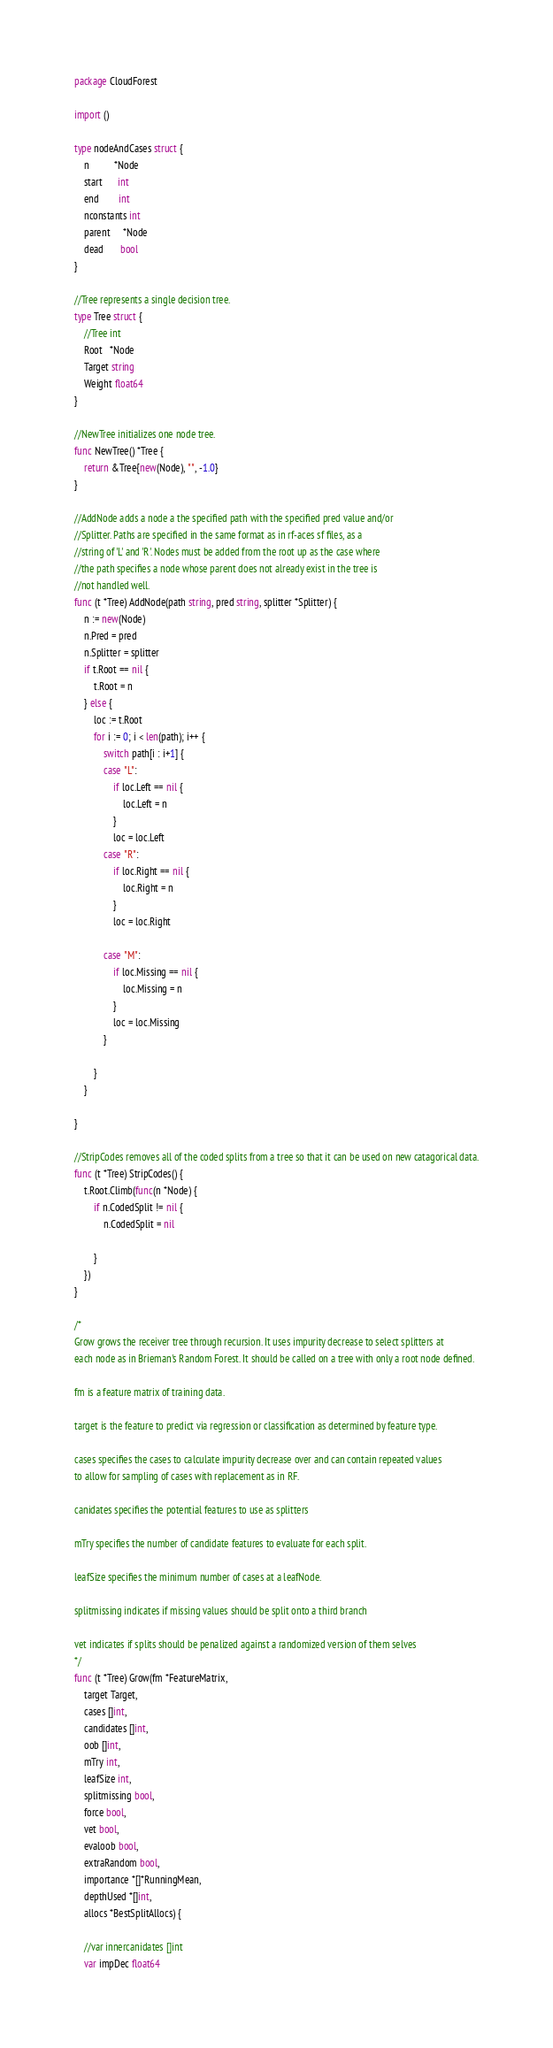<code> <loc_0><loc_0><loc_500><loc_500><_Go_>package CloudForest

import ()

type nodeAndCases struct {
	n          *Node
	start      int
	end        int
	nconstants int
	parent     *Node
	dead       bool
}

//Tree represents a single decision tree.
type Tree struct {
	//Tree int
	Root   *Node
	Target string
	Weight float64
}

//NewTree initializes one node tree.
func NewTree() *Tree {
	return &Tree{new(Node), "", -1.0}
}

//AddNode adds a node a the specified path with the specified pred value and/or
//Splitter. Paths are specified in the same format as in rf-aces sf files, as a
//string of 'L' and 'R'. Nodes must be added from the root up as the case where
//the path specifies a node whose parent does not already exist in the tree is
//not handled well.
func (t *Tree) AddNode(path string, pred string, splitter *Splitter) {
	n := new(Node)
	n.Pred = pred
	n.Splitter = splitter
	if t.Root == nil {
		t.Root = n
	} else {
		loc := t.Root
		for i := 0; i < len(path); i++ {
			switch path[i : i+1] {
			case "L":
				if loc.Left == nil {
					loc.Left = n
				}
				loc = loc.Left
			case "R":
				if loc.Right == nil {
					loc.Right = n
				}
				loc = loc.Right

			case "M":
				if loc.Missing == nil {
					loc.Missing = n
				}
				loc = loc.Missing
			}

		}
	}

}

//StripCodes removes all of the coded splits from a tree so that it can be used on new catagorical data.
func (t *Tree) StripCodes() {
	t.Root.Climb(func(n *Node) {
		if n.CodedSplit != nil {
			n.CodedSplit = nil

		}
	})
}

/*
Grow grows the receiver tree through recursion. It uses impurity decrease to select splitters at
each node as in Brieman's Random Forest. It should be called on a tree with only a root node defined.

fm is a feature matrix of training data.

target is the feature to predict via regression or classification as determined by feature type.

cases specifies the cases to calculate impurity decrease over and can contain repeated values
to allow for sampling of cases with replacement as in RF.

canidates specifies the potential features to use as splitters

mTry specifies the number of candidate features to evaluate for each split.

leafSize specifies the minimum number of cases at a leafNode.

splitmissing indicates if missing values should be split onto a third branch

vet indicates if splits should be penalized against a randomized version of them selves
*/
func (t *Tree) Grow(fm *FeatureMatrix,
	target Target,
	cases []int,
	candidates []int,
	oob []int,
	mTry int,
	leafSize int,
	splitmissing bool,
	force bool,
	vet bool,
	evaloob bool,
	extraRandom bool,
	importance *[]*RunningMean,
	depthUsed *[]int,
	allocs *BestSplitAllocs) {

	//var innercanidates []int
	var impDec float64</code> 